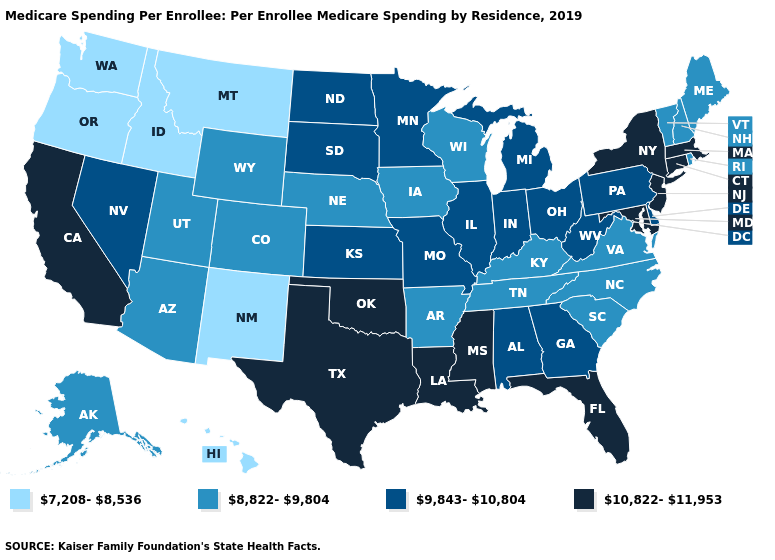What is the value of Alaska?
Answer briefly. 8,822-9,804. Does California have the highest value in the West?
Write a very short answer. Yes. What is the value of Vermont?
Quick response, please. 8,822-9,804. What is the value of West Virginia?
Concise answer only. 9,843-10,804. What is the value of Michigan?
Write a very short answer. 9,843-10,804. What is the value of Louisiana?
Give a very brief answer. 10,822-11,953. What is the value of Utah?
Concise answer only. 8,822-9,804. Does Pennsylvania have a lower value than Massachusetts?
Quick response, please. Yes. What is the value of North Dakota?
Short answer required. 9,843-10,804. What is the value of Kentucky?
Answer briefly. 8,822-9,804. Which states have the lowest value in the USA?
Concise answer only. Hawaii, Idaho, Montana, New Mexico, Oregon, Washington. Does North Dakota have the highest value in the MidWest?
Be succinct. Yes. Among the states that border Maryland , does Virginia have the highest value?
Give a very brief answer. No. Name the states that have a value in the range 7,208-8,536?
Quick response, please. Hawaii, Idaho, Montana, New Mexico, Oregon, Washington. What is the value of Louisiana?
Keep it brief. 10,822-11,953. 